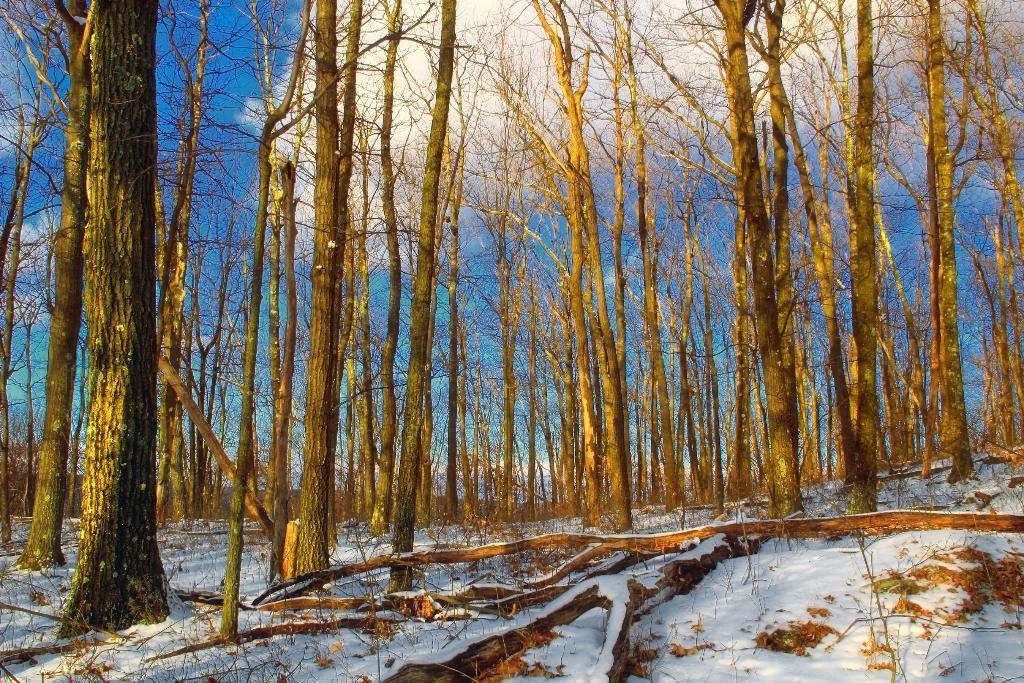In one or two sentences, can you explain what this image depicts? In this image, we can see trees and at the bottom, there is snow. At the top, there are clouds in the sky. 